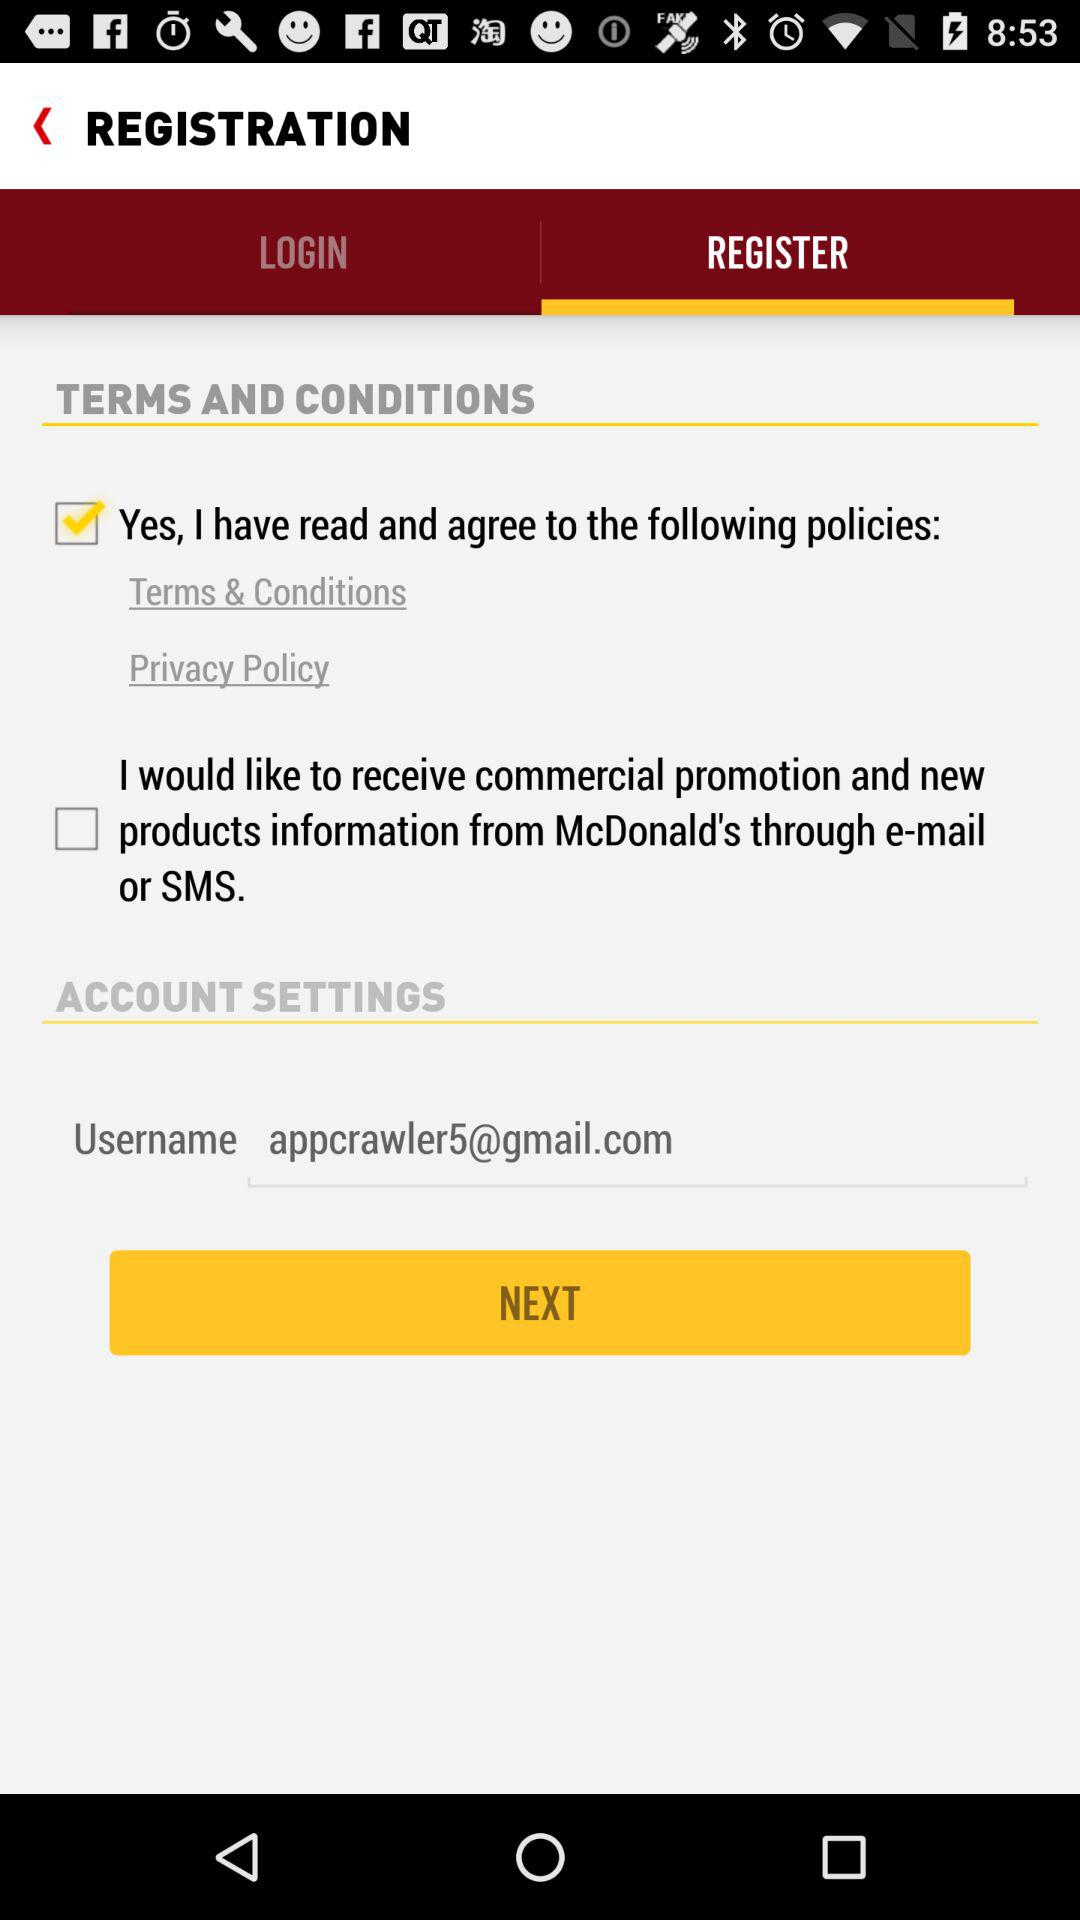Which tab is selected? The selected tab is "REGISTER". 